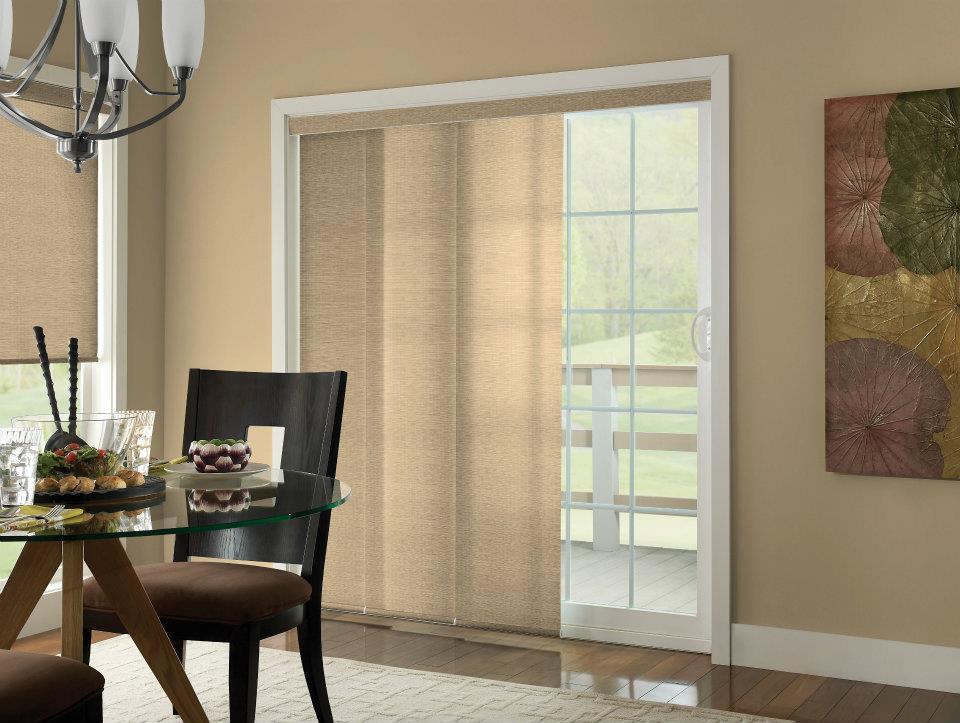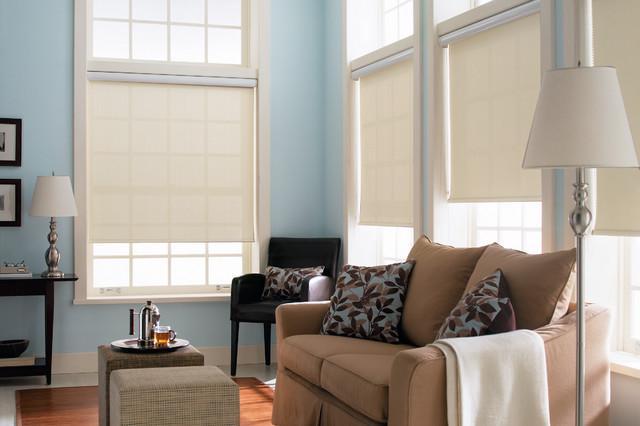The first image is the image on the left, the second image is the image on the right. Examine the images to the left and right. Is the description "An image with a tall lamp at the right includes at least three beige window shades with the upper part of the windows uncovered." accurate? Answer yes or no. Yes. The first image is the image on the left, the second image is the image on the right. For the images shown, is this caption "The left and right image contains a total of five windows raised off the floor." true? Answer yes or no. Yes. 